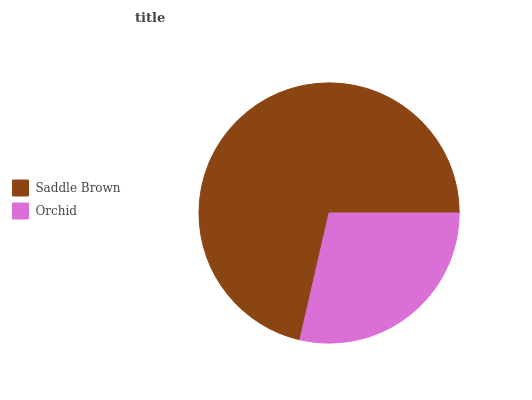Is Orchid the minimum?
Answer yes or no. Yes. Is Saddle Brown the maximum?
Answer yes or no. Yes. Is Orchid the maximum?
Answer yes or no. No. Is Saddle Brown greater than Orchid?
Answer yes or no. Yes. Is Orchid less than Saddle Brown?
Answer yes or no. Yes. Is Orchid greater than Saddle Brown?
Answer yes or no. No. Is Saddle Brown less than Orchid?
Answer yes or no. No. Is Saddle Brown the high median?
Answer yes or no. Yes. Is Orchid the low median?
Answer yes or no. Yes. Is Orchid the high median?
Answer yes or no. No. Is Saddle Brown the low median?
Answer yes or no. No. 